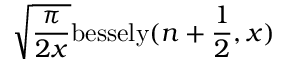Convert formula to latex. <formula><loc_0><loc_0><loc_500><loc_500>\sqrt { \frac { \pi } { 2 x } } b e s s e l y ( n + \frac { 1 } { 2 } , x )</formula> 